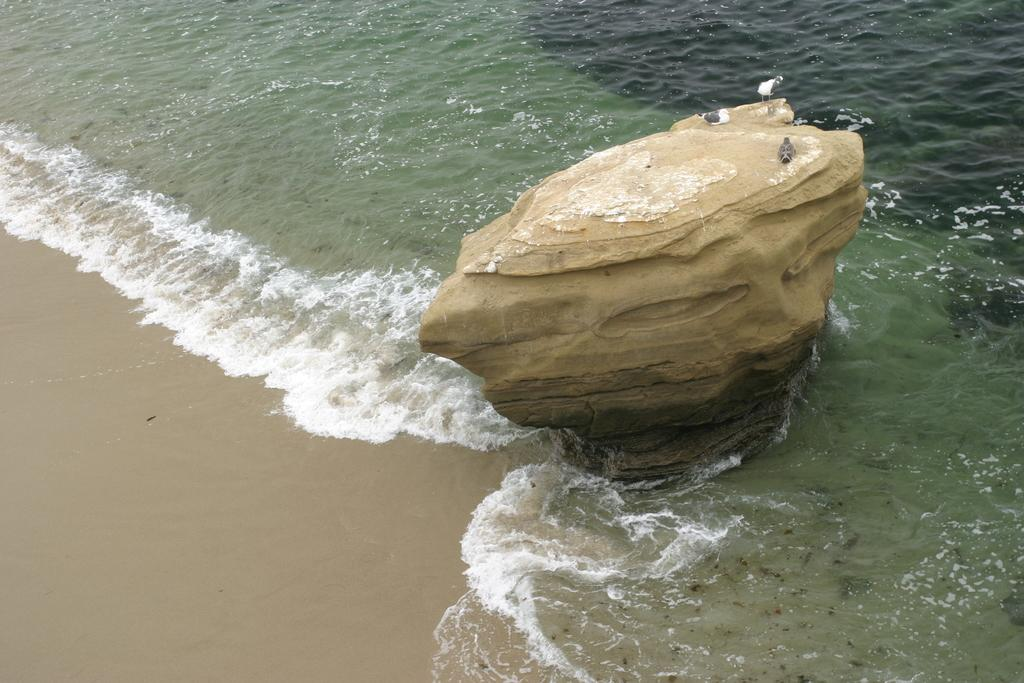What animals are on the rock in the image? There are birds on a rock in the image. What type of environment is depicted in the image? There is water and ground visible in the image. What type of wound can be seen on the bird's wing in the image? There is no wound visible on the bird's wing in the image, as the birds appear to be healthy and uninjured. 